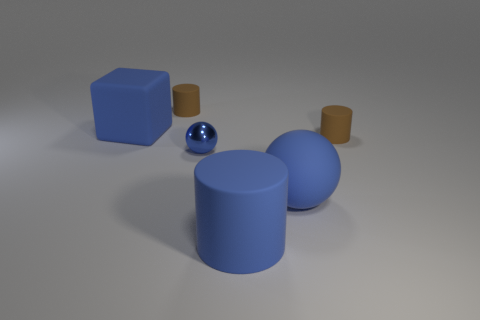Add 3 tiny metal things. How many objects exist? 9 Subtract all balls. How many objects are left? 4 Add 1 big blue cylinders. How many big blue cylinders exist? 2 Subtract 0 cyan cubes. How many objects are left? 6 Subtract all small brown cylinders. Subtract all tiny brown cylinders. How many objects are left? 2 Add 2 blue rubber things. How many blue rubber things are left? 5 